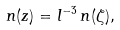<formula> <loc_0><loc_0><loc_500><loc_500>n ( z ) = l ^ { - 3 } \, n ( \zeta ) ,</formula> 